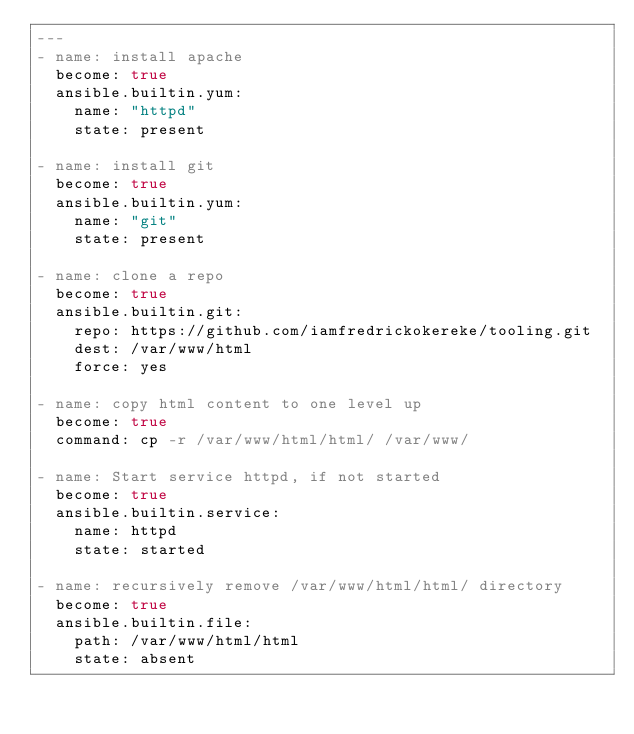Convert code to text. <code><loc_0><loc_0><loc_500><loc_500><_YAML_>---
- name: install apache
  become: true
  ansible.builtin.yum:
    name: "httpd"
    state: present

- name: install git
  become: true
  ansible.builtin.yum:
    name: "git"
    state: present

- name: clone a repo
  become: true
  ansible.builtin.git:
    repo: https://github.com/iamfredrickokereke/tooling.git
    dest: /var/www/html
    force: yes

- name: copy html content to one level up
  become: true
  command: cp -r /var/www/html/html/ /var/www/

- name: Start service httpd, if not started
  become: true
  ansible.builtin.service:
    name: httpd
    state: started

- name: recursively remove /var/www/html/html/ directory
  become: true
  ansible.builtin.file:
    path: /var/www/html/html
    state: absent
</code> 